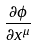Convert formula to latex. <formula><loc_0><loc_0><loc_500><loc_500>\frac { \partial \phi } { \partial x ^ { \mu } }</formula> 